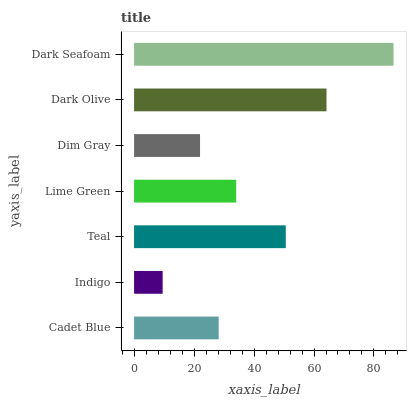Is Indigo the minimum?
Answer yes or no. Yes. Is Dark Seafoam the maximum?
Answer yes or no. Yes. Is Teal the minimum?
Answer yes or no. No. Is Teal the maximum?
Answer yes or no. No. Is Teal greater than Indigo?
Answer yes or no. Yes. Is Indigo less than Teal?
Answer yes or no. Yes. Is Indigo greater than Teal?
Answer yes or no. No. Is Teal less than Indigo?
Answer yes or no. No. Is Lime Green the high median?
Answer yes or no. Yes. Is Lime Green the low median?
Answer yes or no. Yes. Is Dark Seafoam the high median?
Answer yes or no. No. Is Dark Seafoam the low median?
Answer yes or no. No. 